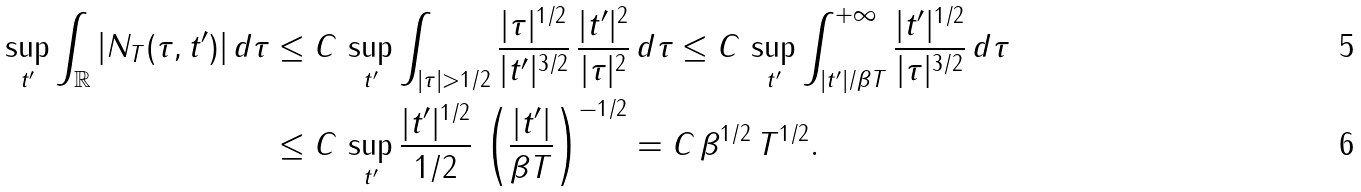<formula> <loc_0><loc_0><loc_500><loc_500>\sup _ { t ^ { \prime } } \int _ { \mathbb { R } } | N _ { T } ( \tau , t ^ { \prime } ) | \, d \tau & \leq C \, \sup _ { t ^ { \prime } } \int _ { | \tau | > 1 / 2 } \frac { | \tau | ^ { 1 / 2 } } { | t ^ { \prime } | ^ { 3 / 2 } } \, \frac { | t ^ { \prime } | ^ { 2 } } { | \tau | ^ { 2 } } \, d \tau \leq C \, \sup _ { t ^ { \prime } } \int _ { | t ^ { \prime } | / \beta T } ^ { + \infty } \frac { | t ^ { \prime } | ^ { 1 / 2 } } { | \tau | ^ { 3 / 2 } } \, d \tau \\ & \leq C \, \sup _ { t ^ { \prime } } \frac { | t ^ { \prime } | ^ { 1 / 2 } } { 1 / 2 } \, \left ( \frac { | t ^ { \prime } | } { \beta T } \right ) ^ { - 1 / 2 } = C \, \beta ^ { 1 / 2 } \, T ^ { 1 / 2 } .</formula> 